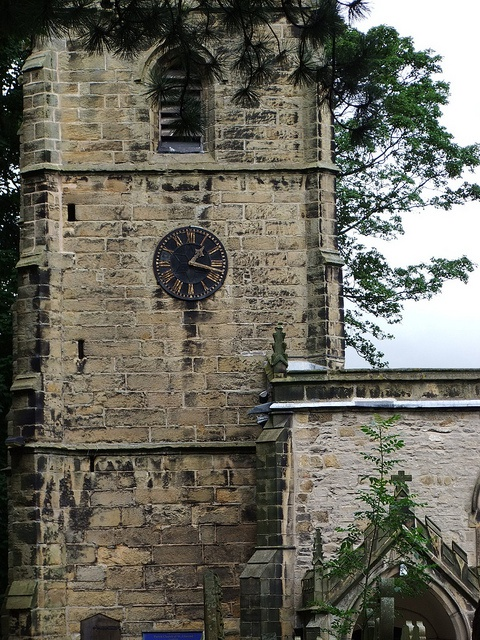Describe the objects in this image and their specific colors. I can see a clock in black and gray tones in this image. 